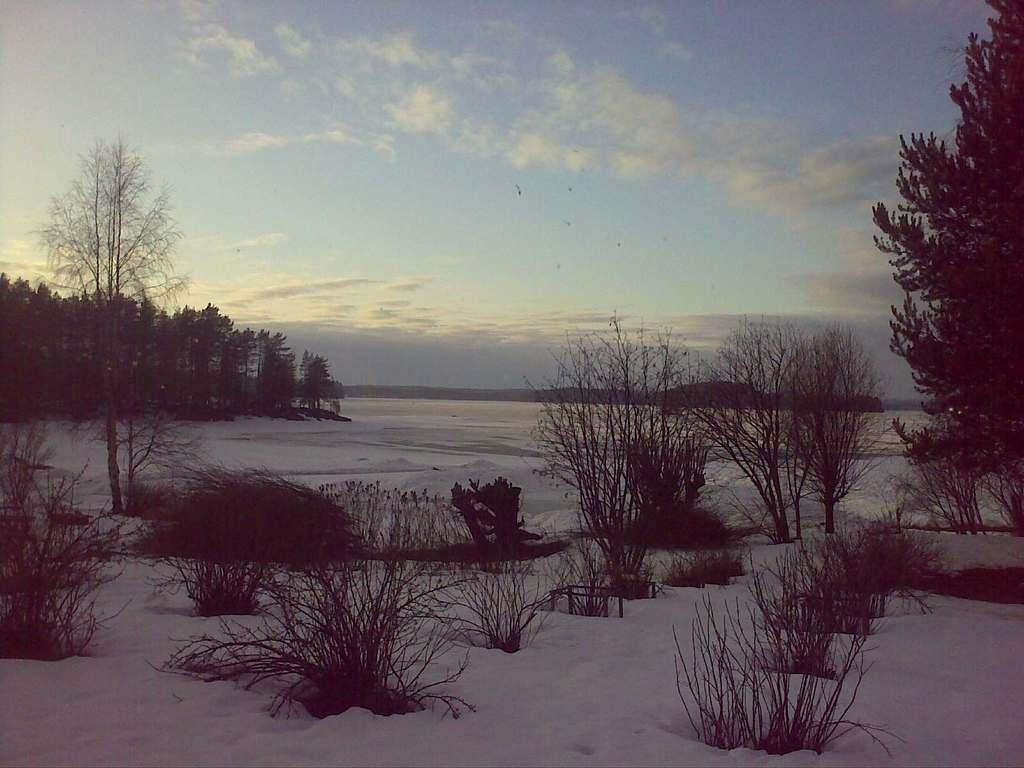What type of vegetation can be seen in the image? There are trees and dried plants in the image. What is the ground covered with in the image? Snow is visible in the image. What can be seen in the background of the image? There are hills in the background of the image. What is visible at the top of the image? The sky is visible at the top of the image, and clouds are present in the sky. What type of chin can be seen on the snake in the image? There is no snake present in the image, so there is no chin to observe. 